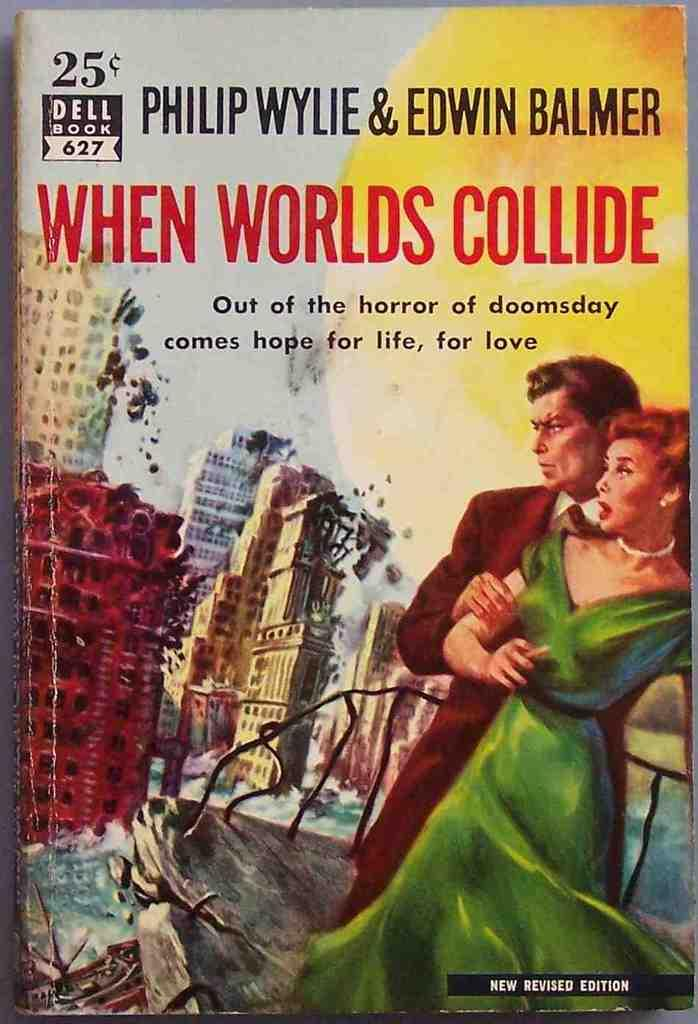Provide a one-sentence caption for the provided image. The book When Worlds Collide only cost 25 cents when it came out. 